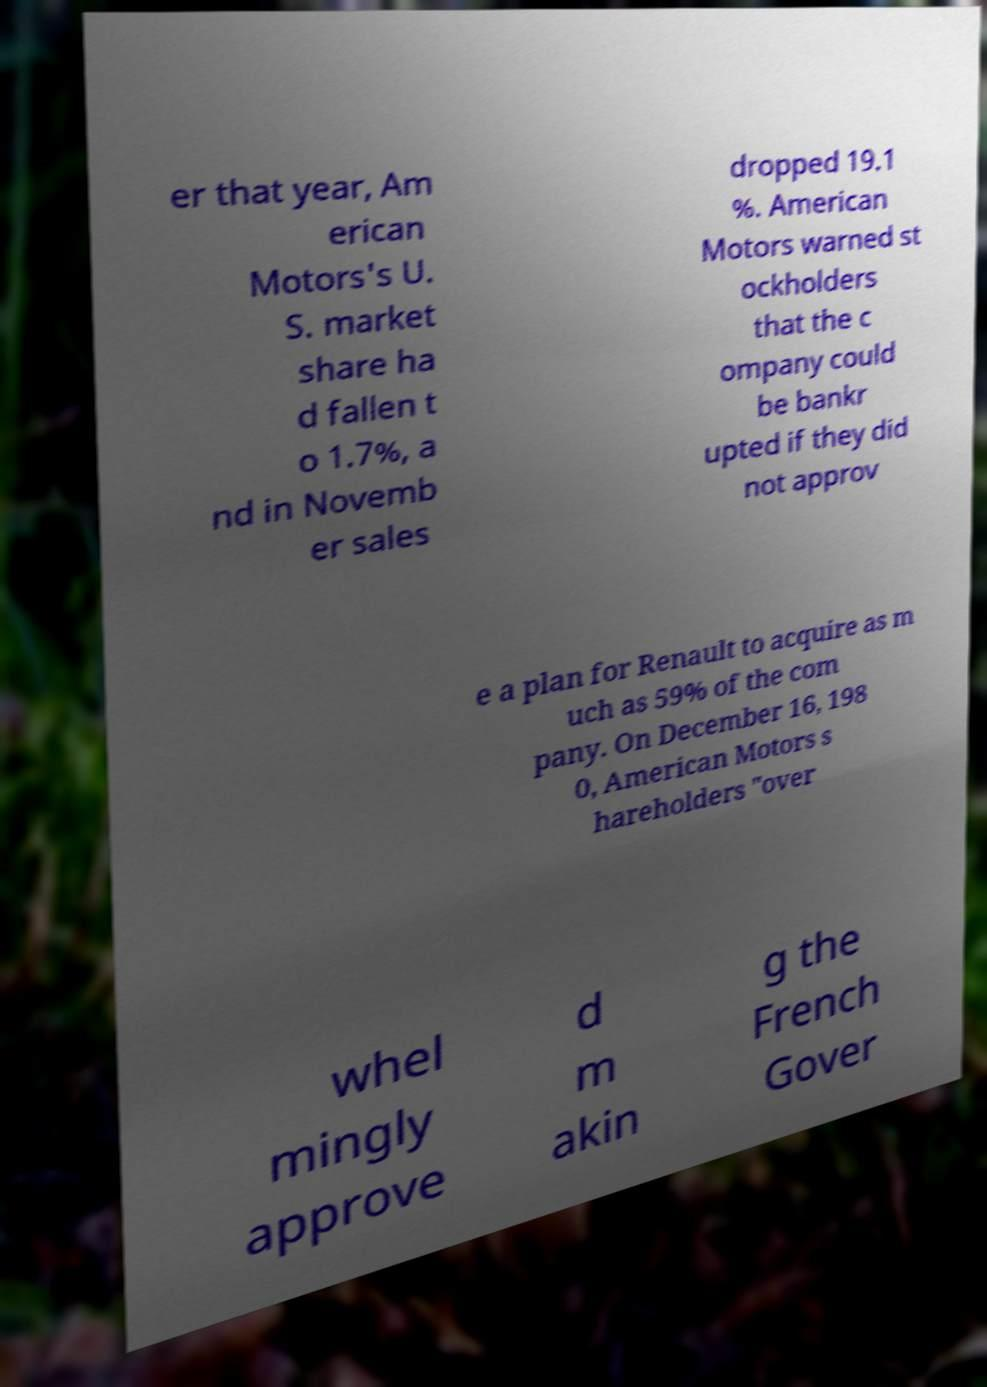Can you read and provide the text displayed in the image?This photo seems to have some interesting text. Can you extract and type it out for me? er that year, Am erican Motors's U. S. market share ha d fallen t o 1.7%, a nd in Novemb er sales dropped 19.1 %. American Motors warned st ockholders that the c ompany could be bankr upted if they did not approv e a plan for Renault to acquire as m uch as 59% of the com pany. On December 16, 198 0, American Motors s hareholders "over whel mingly approve d m akin g the French Gover 